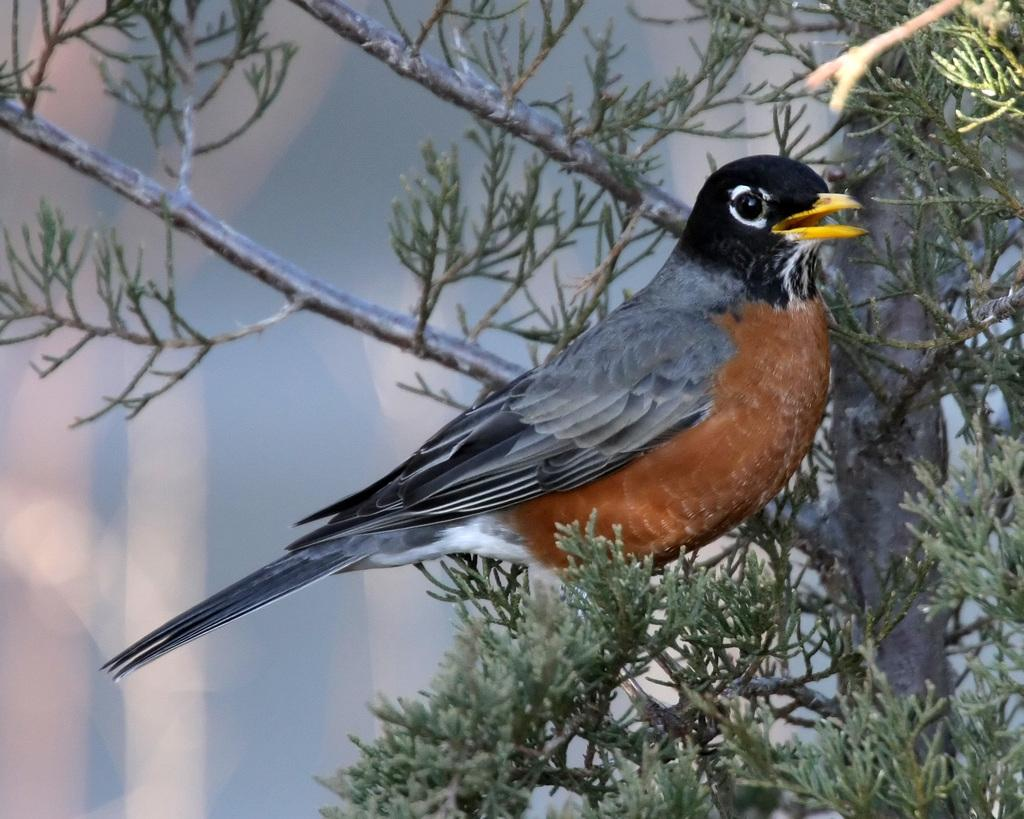What type of animal can be seen in the image? There is a bird in the image. Where is the bird located in the image? The bird is standing on a branch. What is the branch a part of? The branch is part of a tree. What can be seen in the image besides the bird and the branch? There are leaves visible in the image. What is visible in the background of the image? There is at least one tree in the background of the image. What type of crime is the bird committing in the image? There is no crime being committed in the image; it is a bird standing on a branch. How does the bird's heart rate compare to that of a human in the image? There is no information about the bird's heart rate or a comparison to a human's heart rate in the image. 